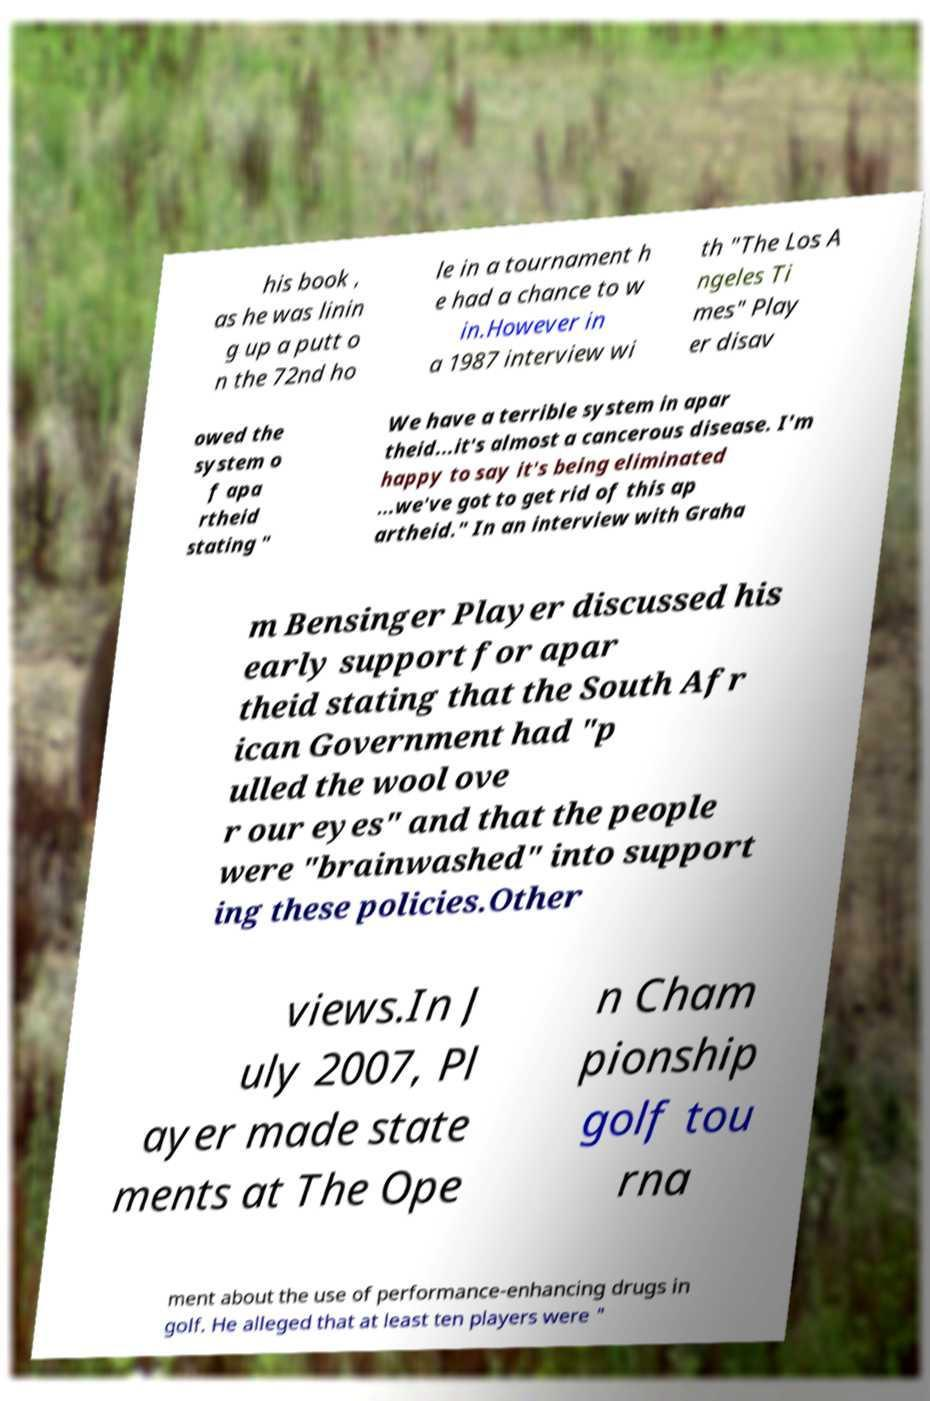Can you read and provide the text displayed in the image?This photo seems to have some interesting text. Can you extract and type it out for me? his book , as he was linin g up a putt o n the 72nd ho le in a tournament h e had a chance to w in.However in a 1987 interview wi th "The Los A ngeles Ti mes" Play er disav owed the system o f apa rtheid stating " We have a terrible system in apar theid...it's almost a cancerous disease. I'm happy to say it's being eliminated ...we've got to get rid of this ap artheid." In an interview with Graha m Bensinger Player discussed his early support for apar theid stating that the South Afr ican Government had "p ulled the wool ove r our eyes" and that the people were "brainwashed" into support ing these policies.Other views.In J uly 2007, Pl ayer made state ments at The Ope n Cham pionship golf tou rna ment about the use of performance-enhancing drugs in golf. He alleged that at least ten players were " 